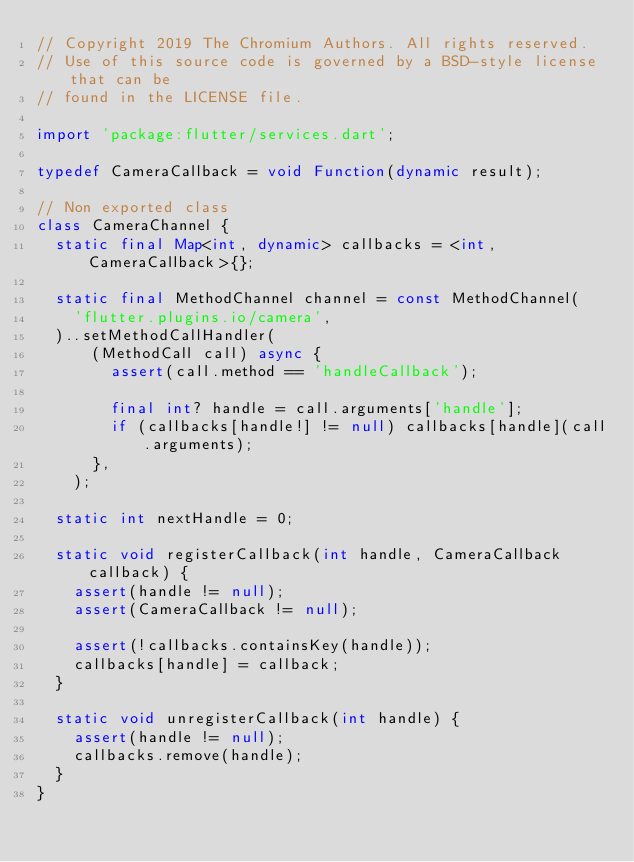<code> <loc_0><loc_0><loc_500><loc_500><_Dart_>// Copyright 2019 The Chromium Authors. All rights reserved.
// Use of this source code is governed by a BSD-style license that can be
// found in the LICENSE file.

import 'package:flutter/services.dart';

typedef CameraCallback = void Function(dynamic result);

// Non exported class
class CameraChannel {
  static final Map<int, dynamic> callbacks = <int, CameraCallback>{};

  static final MethodChannel channel = const MethodChannel(
    'flutter.plugins.io/camera',
  )..setMethodCallHandler(
      (MethodCall call) async {
        assert(call.method == 'handleCallback');

        final int? handle = call.arguments['handle'];
        if (callbacks[handle!] != null) callbacks[handle](call.arguments);
      },
    );

  static int nextHandle = 0;

  static void registerCallback(int handle, CameraCallback callback) {
    assert(handle != null);
    assert(CameraCallback != null);

    assert(!callbacks.containsKey(handle));
    callbacks[handle] = callback;
  }

  static void unregisterCallback(int handle) {
    assert(handle != null);
    callbacks.remove(handle);
  }
}
</code> 